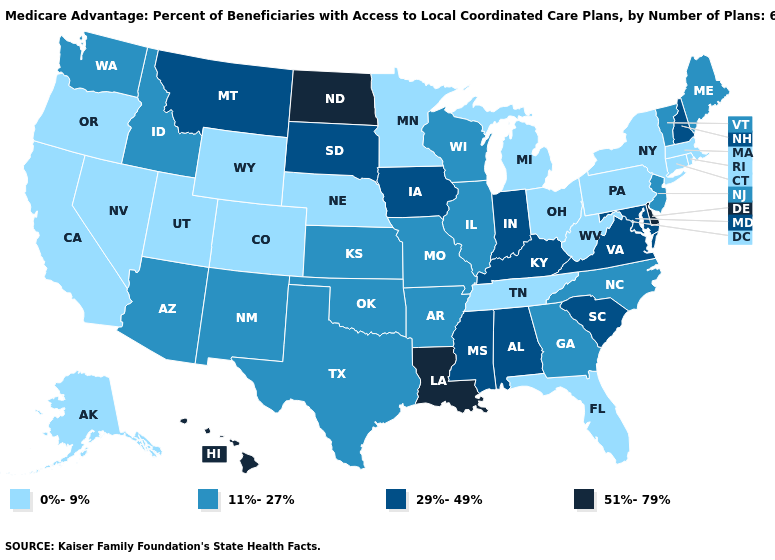What is the lowest value in the USA?
Answer briefly. 0%-9%. What is the value of Pennsylvania?
Write a very short answer. 0%-9%. Name the states that have a value in the range 0%-9%?
Short answer required. California, Colorado, Connecticut, Florida, Massachusetts, Michigan, Minnesota, Nebraska, Nevada, New York, Ohio, Oregon, Pennsylvania, Rhode Island, Alaska, Tennessee, Utah, West Virginia, Wyoming. Does the map have missing data?
Write a very short answer. No. What is the highest value in the USA?
Give a very brief answer. 51%-79%. What is the value of West Virginia?
Keep it brief. 0%-9%. Name the states that have a value in the range 11%-27%?
Quick response, please. Georgia, Idaho, Illinois, Kansas, Maine, Missouri, North Carolina, New Jersey, New Mexico, Oklahoma, Texas, Vermont, Washington, Wisconsin, Arkansas, Arizona. Among the states that border New Mexico , does Colorado have the highest value?
Write a very short answer. No. Does Michigan have the highest value in the MidWest?
Short answer required. No. What is the lowest value in the West?
Short answer required. 0%-9%. What is the value of Kansas?
Quick response, please. 11%-27%. What is the value of Virginia?
Write a very short answer. 29%-49%. Name the states that have a value in the range 51%-79%?
Answer briefly. Delaware, Hawaii, Louisiana, North Dakota. What is the value of Oregon?
Write a very short answer. 0%-9%. Name the states that have a value in the range 51%-79%?
Be succinct. Delaware, Hawaii, Louisiana, North Dakota. 